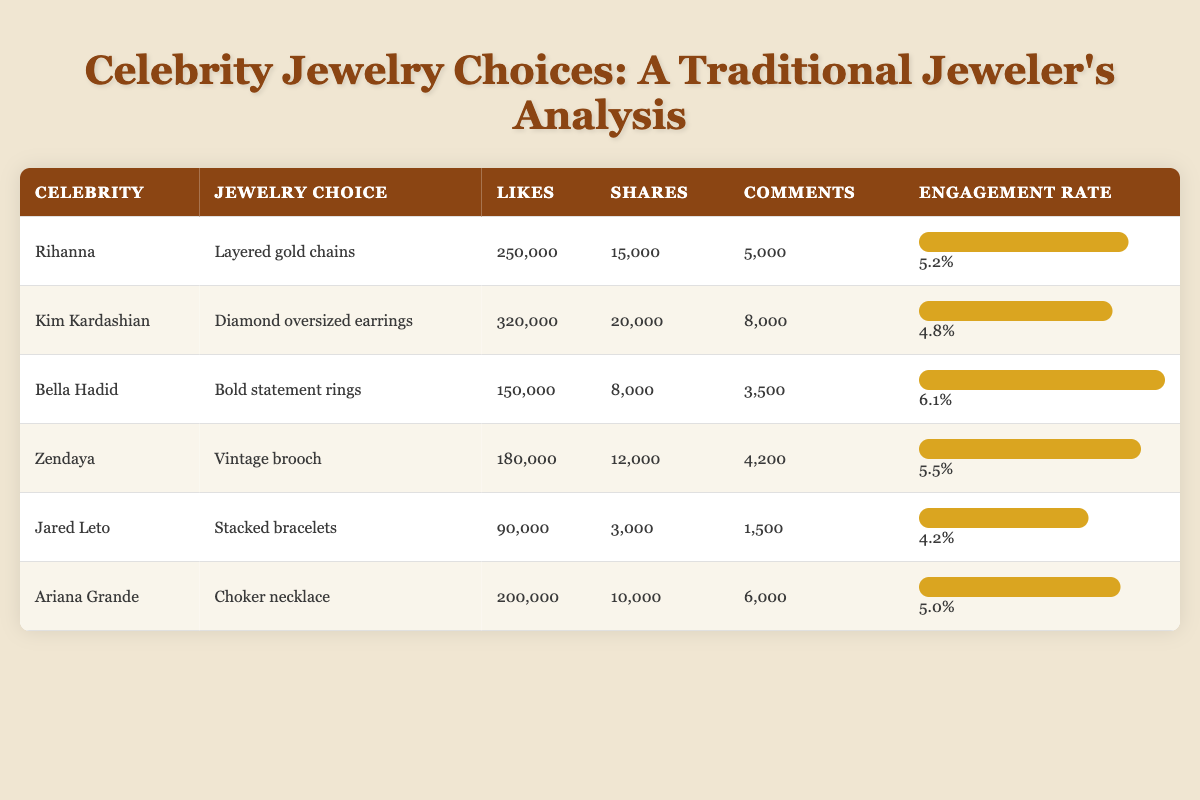What jewelry choice received the most likes? The table shows "Kim Kardashian" with "Diamond oversized earrings" receiving the highest likes, totaling 320,000.
Answer: Diamond oversized earrings Which celebrity had the lowest engagement rate? In the table, "Jared Leto" had the lowest engagement rate at 4.2%.
Answer: 4.2% What is the total number of comments from all celebrities? Adding the comments together: 5000 (Rihanna) + 8000 (Kim K) + 3500 (Bella) + 4200 (Zendaya) + 1500 (Jared) + 6000 (Ariana) = 19,200 comments.
Answer: 19200 Is Ariana Grande's jewelry choice more popular than Bella Hadid's based on likes? Ariana Grande's "Choker necklace" received 200,000 likes, while Bella Hadid's "Bold statement rings" received 150,000 likes, indicating Ariana's choice is more popular.
Answer: Yes Which celebrity had a higher engagement rate: Zendaya or Rihanna? Zendaya had an engagement rate of 5.5%, while Rihanna had 5.2%. Therefore, Zendaya had a higher engagement rate.
Answer: Zendaya What percentage of likes did Bella Hadid's jewelry choice receive compared to Kim Kardashian's? Bella Hadid received 150,000 likes and Kim Kardashian received 320,000 likes. To find the percentage of Bella's likes compared to Kim's: (150000 / 320000) * 100 = 46.88%.
Answer: 46.88% Which jewelry choice had the highest number of shares? The table indicates "Kim Kardashian" with "Diamond oversized earrings" had the highest shares, totaling 20,000.
Answer: Diamond oversized earrings What is the average engagement rate of the celebrities listed? To find the average engagement rate: (5.2 + 4.8 + 6.1 + 5.5 + 4.2 + 5.0) / 6 = 5.23.
Answer: 5.23 